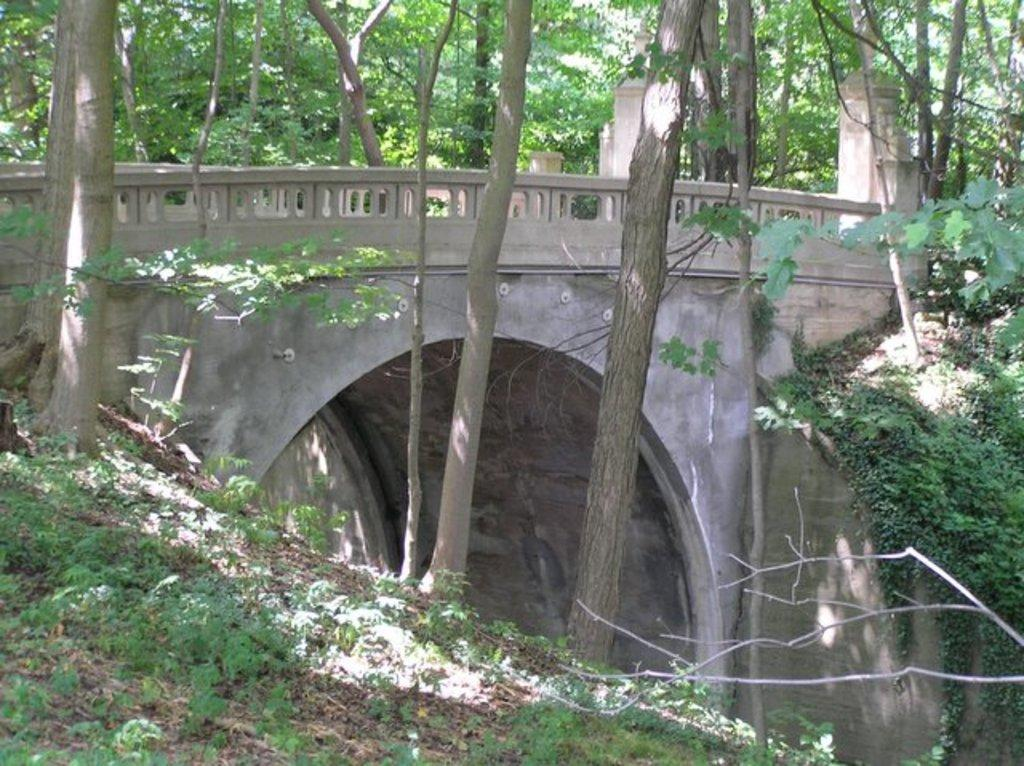What type of vegetation is present on the ground in the front of the image? There is grass on the ground in the front of the image. What can be seen in the center of the image? There are trees in the center of the image. What structure is visible in the background of the image? There is a bridge in the background of the image. What else is present behind the bridge in the background of the image? There are trees behind the bridge in the background of the image. Can you see any crackers or cows in the image? No, there are no crackers or cows present in the image. What type of fowl can be seen flying over the bridge in the image? There are no fowl visible in the image; only trees, grass, and the bridge are present. 